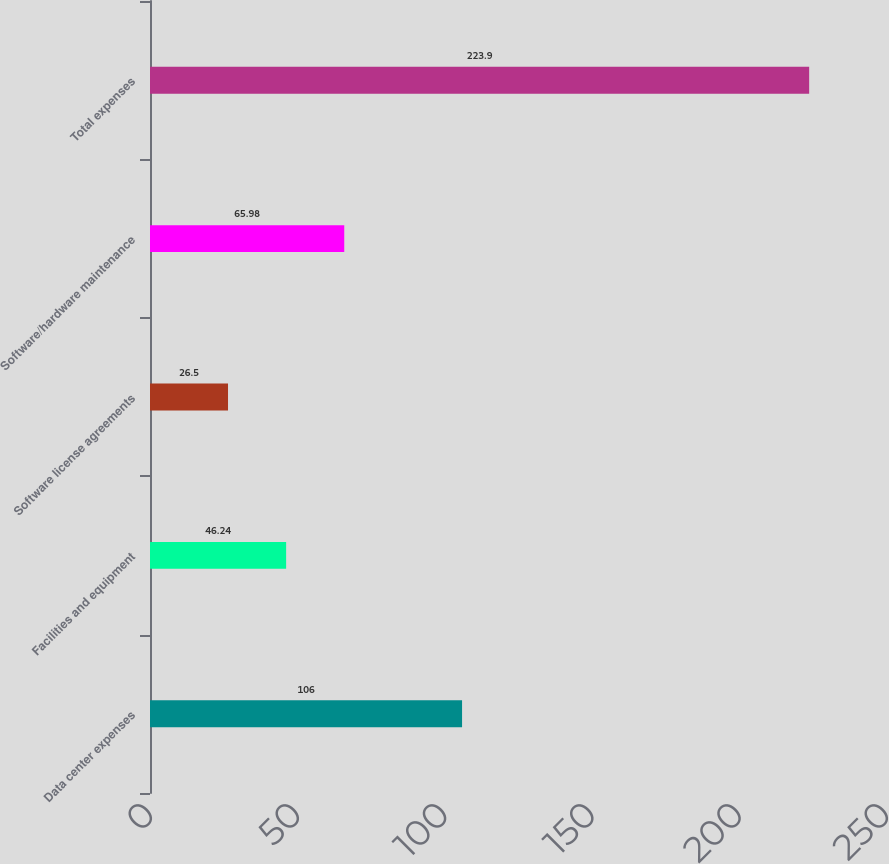<chart> <loc_0><loc_0><loc_500><loc_500><bar_chart><fcel>Data center expenses<fcel>Facilities and equipment<fcel>Software license agreements<fcel>Software/hardware maintenance<fcel>Total expenses<nl><fcel>106<fcel>46.24<fcel>26.5<fcel>65.98<fcel>223.9<nl></chart> 